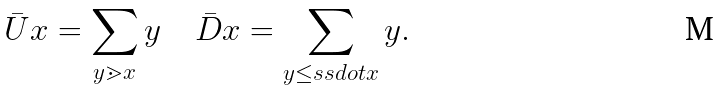Convert formula to latex. <formula><loc_0><loc_0><loc_500><loc_500>\bar { U } x = \sum _ { y \gtrdot x } y \quad \bar { D } x = \sum _ { y \leq s s d o t x } y .</formula> 